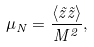<formula> <loc_0><loc_0><loc_500><loc_500>\mu _ { N } = \frac { \langle \tilde { z } \tilde { z } \rangle } { M ^ { 2 } } ,</formula> 